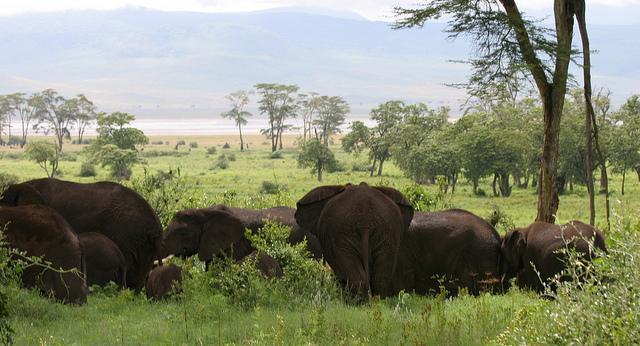How many elephants are in the picture?
Give a very brief answer. 6. How many people are behind the bus?
Give a very brief answer. 0. 